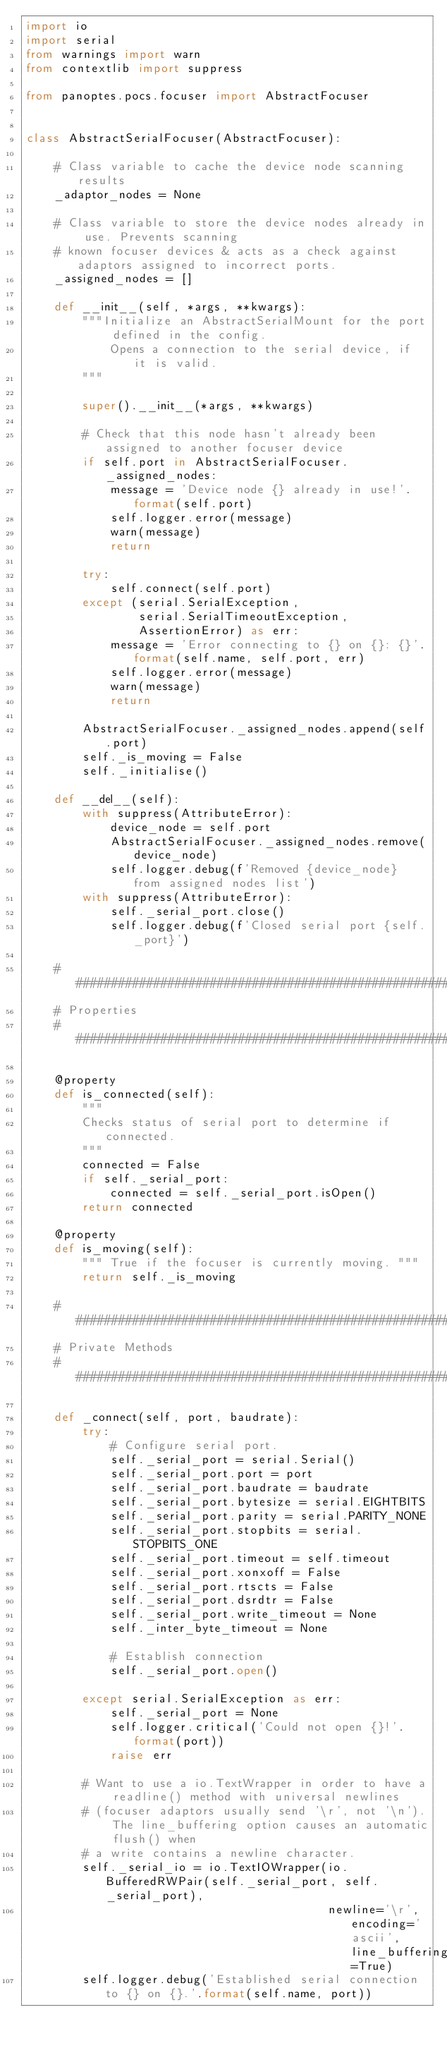Convert code to text. <code><loc_0><loc_0><loc_500><loc_500><_Python_>import io
import serial
from warnings import warn
from contextlib import suppress

from panoptes.pocs.focuser import AbstractFocuser


class AbstractSerialFocuser(AbstractFocuser):

    # Class variable to cache the device node scanning results
    _adaptor_nodes = None

    # Class variable to store the device nodes already in use. Prevents scanning
    # known focuser devices & acts as a check against adaptors assigned to incorrect ports.
    _assigned_nodes = []

    def __init__(self, *args, **kwargs):
        """Initialize an AbstractSerialMount for the port defined in the config.
            Opens a connection to the serial device, if it is valid.
        """

        super().__init__(*args, **kwargs)

        # Check that this node hasn't already been assigned to another focuser device
        if self.port in AbstractSerialFocuser._assigned_nodes:
            message = 'Device node {} already in use!'.format(self.port)
            self.logger.error(message)
            warn(message)
            return

        try:
            self.connect(self.port)
        except (serial.SerialException,
                serial.SerialTimeoutException,
                AssertionError) as err:
            message = 'Error connecting to {} on {}: {}'.format(self.name, self.port, err)
            self.logger.error(message)
            warn(message)
            return

        AbstractSerialFocuser._assigned_nodes.append(self.port)
        self._is_moving = False
        self._initialise()

    def __del__(self):
        with suppress(AttributeError):
            device_node = self.port
            AbstractSerialFocuser._assigned_nodes.remove(device_node)
            self.logger.debug(f'Removed {device_node} from assigned nodes list')
        with suppress(AttributeError):
            self._serial_port.close()
            self.logger.debug(f'Closed serial port {self._port}')

    ##################################################################################################
    # Properties
    ##################################################################################################

    @property
    def is_connected(self):
        """
        Checks status of serial port to determine if connected.
        """
        connected = False
        if self._serial_port:
            connected = self._serial_port.isOpen()
        return connected

    @property
    def is_moving(self):
        """ True if the focuser is currently moving. """
        return self._is_moving

    ##################################################################################################
    # Private Methods
    ##################################################################################################

    def _connect(self, port, baudrate):
        try:
            # Configure serial port.
            self._serial_port = serial.Serial()
            self._serial_port.port = port
            self._serial_port.baudrate = baudrate
            self._serial_port.bytesize = serial.EIGHTBITS
            self._serial_port.parity = serial.PARITY_NONE
            self._serial_port.stopbits = serial.STOPBITS_ONE
            self._serial_port.timeout = self.timeout
            self._serial_port.xonxoff = False
            self._serial_port.rtscts = False
            self._serial_port.dsrdtr = False
            self._serial_port.write_timeout = None
            self._inter_byte_timeout = None

            # Establish connection
            self._serial_port.open()

        except serial.SerialException as err:
            self._serial_port = None
            self.logger.critical('Could not open {}!'.format(port))
            raise err

        # Want to use a io.TextWrapper in order to have a readline() method with universal newlines
        # (focuser adaptors usually send '\r', not '\n'). The line_buffering option causes an automatic flush() when
        # a write contains a newline character.
        self._serial_io = io.TextIOWrapper(io.BufferedRWPair(self._serial_port, self._serial_port),
                                           newline='\r', encoding='ascii', line_buffering=True)
        self.logger.debug('Established serial connection to {} on {}.'.format(self.name, port))
</code> 